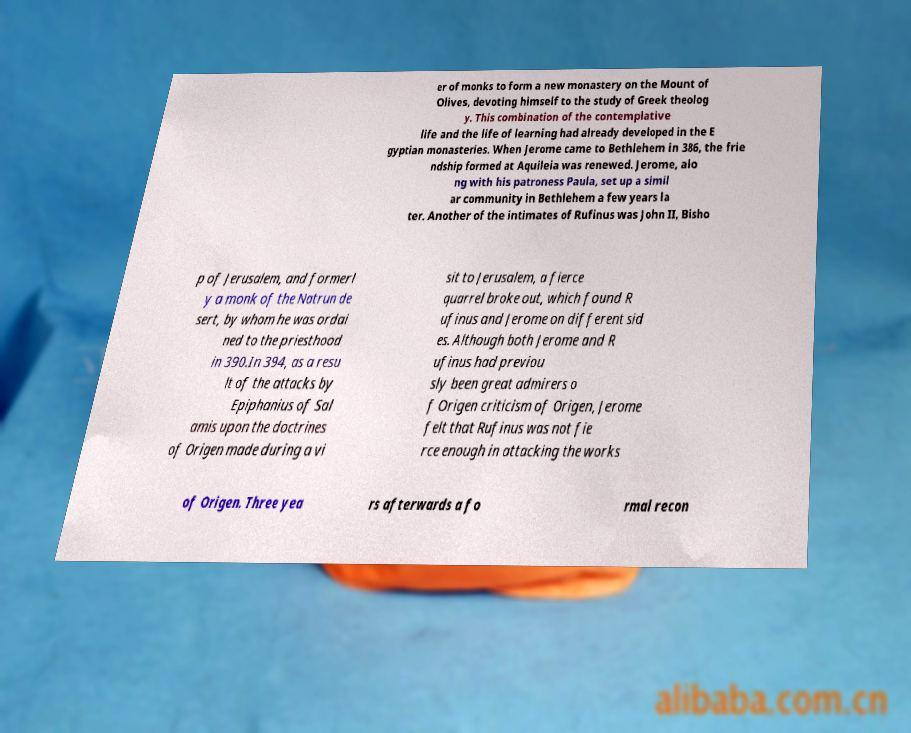Could you assist in decoding the text presented in this image and type it out clearly? er of monks to form a new monastery on the Mount of Olives, devoting himself to the study of Greek theolog y. This combination of the contemplative life and the life of learning had already developed in the E gyptian monasteries. When Jerome came to Bethlehem in 386, the frie ndship formed at Aquileia was renewed. Jerome, alo ng with his patroness Paula, set up a simil ar community in Bethlehem a few years la ter. Another of the intimates of Rufinus was John II, Bisho p of Jerusalem, and formerl y a monk of the Natrun de sert, by whom he was ordai ned to the priesthood in 390.In 394, as a resu lt of the attacks by Epiphanius of Sal amis upon the doctrines of Origen made during a vi sit to Jerusalem, a fierce quarrel broke out, which found R ufinus and Jerome on different sid es. Although both Jerome and R ufinus had previou sly been great admirers o f Origen criticism of Origen, Jerome felt that Rufinus was not fie rce enough in attacking the works of Origen. Three yea rs afterwards a fo rmal recon 